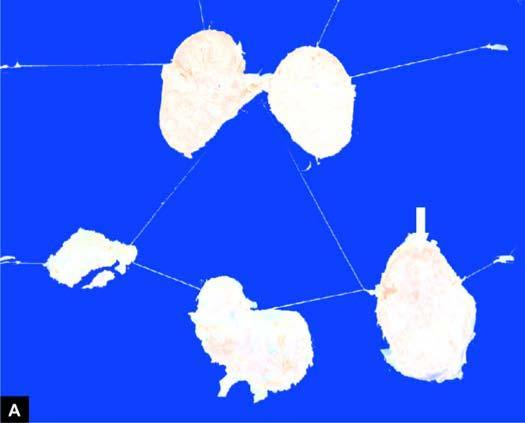does section of matted mass of lymph nodes show merging capsules and large areas of caseation necrosis?
Answer the question using a single word or phrase. Yes 